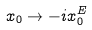Convert formula to latex. <formula><loc_0><loc_0><loc_500><loc_500>x _ { 0 } \rightarrow - i x _ { 0 } ^ { E }</formula> 